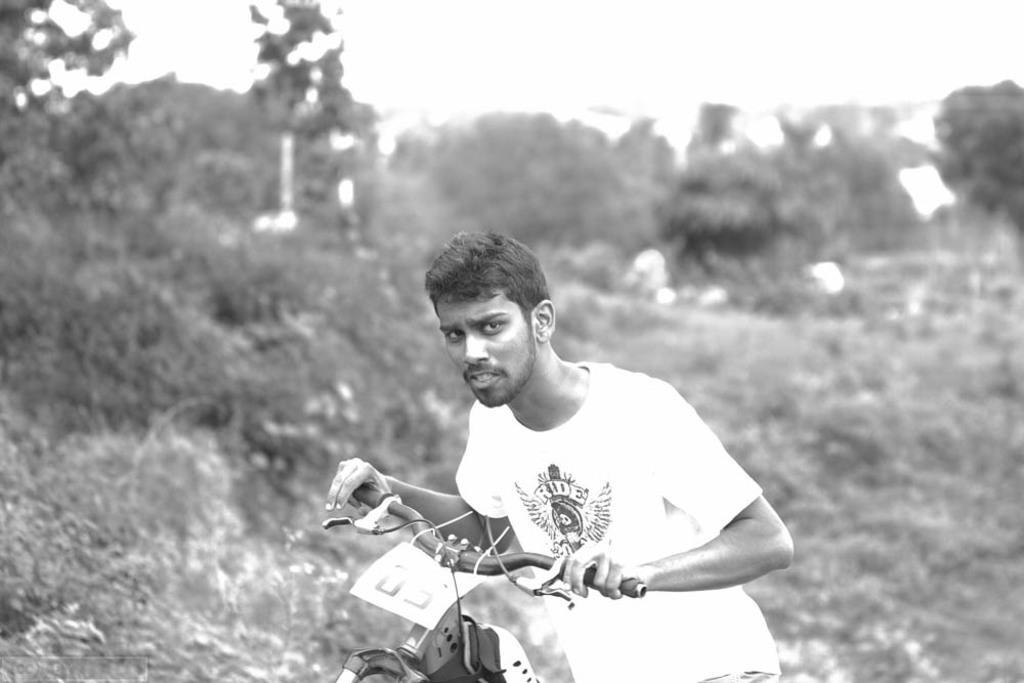In one or two sentences, can you explain what this image depicts? This is black and white picture,there is a man holding vehicle handle and we can see sticker on this vehicle. In the background it is blur. 